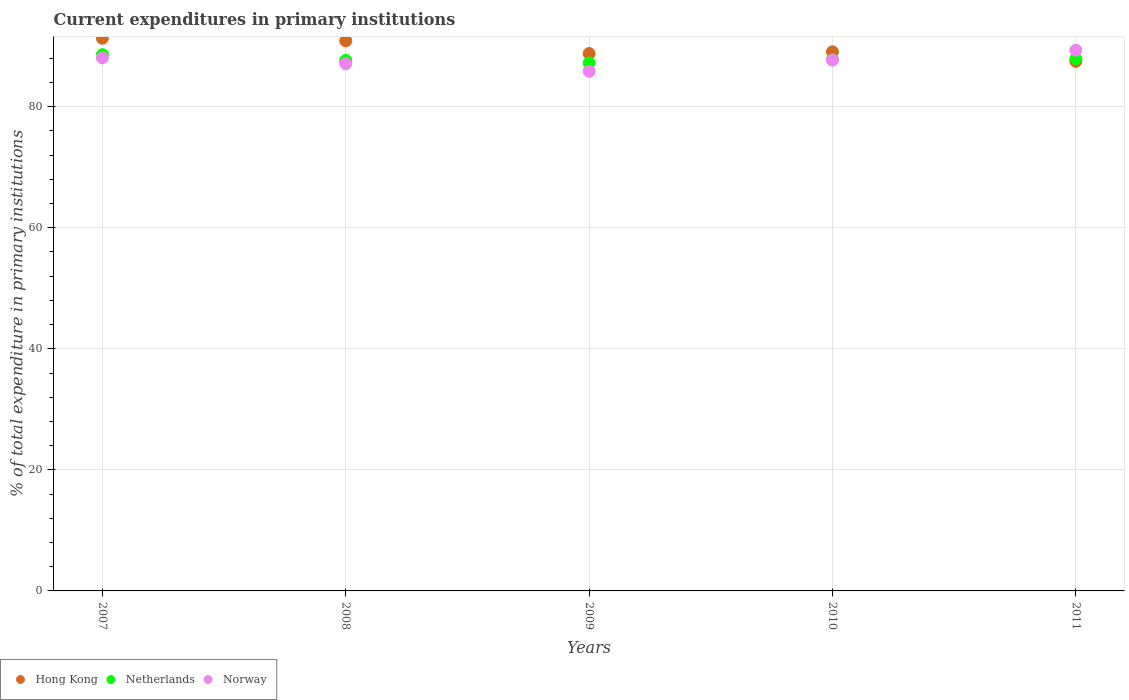Is the number of dotlines equal to the number of legend labels?
Your answer should be very brief. Yes. What is the current expenditures in primary institutions in Netherlands in 2007?
Your answer should be very brief. 88.61. Across all years, what is the maximum current expenditures in primary institutions in Norway?
Provide a short and direct response. 89.34. Across all years, what is the minimum current expenditures in primary institutions in Norway?
Keep it short and to the point. 85.87. In which year was the current expenditures in primary institutions in Norway maximum?
Your answer should be very brief. 2011. What is the total current expenditures in primary institutions in Netherlands in the graph?
Give a very brief answer. 439.27. What is the difference between the current expenditures in primary institutions in Netherlands in 2007 and that in 2010?
Your response must be concise. 0.79. What is the difference between the current expenditures in primary institutions in Hong Kong in 2010 and the current expenditures in primary institutions in Norway in 2009?
Keep it short and to the point. 3.21. What is the average current expenditures in primary institutions in Norway per year?
Your response must be concise. 87.62. In the year 2009, what is the difference between the current expenditures in primary institutions in Netherlands and current expenditures in primary institutions in Hong Kong?
Provide a succinct answer. -1.57. What is the ratio of the current expenditures in primary institutions in Hong Kong in 2007 to that in 2011?
Offer a terse response. 1.04. What is the difference between the highest and the second highest current expenditures in primary institutions in Netherlands?
Your answer should be compact. 0.66. What is the difference between the highest and the lowest current expenditures in primary institutions in Netherlands?
Your answer should be compact. 1.38. Is the sum of the current expenditures in primary institutions in Netherlands in 2008 and 2009 greater than the maximum current expenditures in primary institutions in Hong Kong across all years?
Keep it short and to the point. Yes. Is it the case that in every year, the sum of the current expenditures in primary institutions in Netherlands and current expenditures in primary institutions in Hong Kong  is greater than the current expenditures in primary institutions in Norway?
Provide a short and direct response. Yes. What is the difference between two consecutive major ticks on the Y-axis?
Provide a succinct answer. 20. Does the graph contain any zero values?
Provide a short and direct response. No. Where does the legend appear in the graph?
Provide a short and direct response. Bottom left. What is the title of the graph?
Ensure brevity in your answer.  Current expenditures in primary institutions. Does "Greenland" appear as one of the legend labels in the graph?
Provide a succinct answer. No. What is the label or title of the X-axis?
Provide a short and direct response. Years. What is the label or title of the Y-axis?
Make the answer very short. % of total expenditure in primary institutions. What is the % of total expenditure in primary institutions in Hong Kong in 2007?
Make the answer very short. 91.32. What is the % of total expenditure in primary institutions of Netherlands in 2007?
Make the answer very short. 88.61. What is the % of total expenditure in primary institutions of Norway in 2007?
Give a very brief answer. 88.1. What is the % of total expenditure in primary institutions of Hong Kong in 2008?
Your response must be concise. 90.89. What is the % of total expenditure in primary institutions of Netherlands in 2008?
Ensure brevity in your answer.  87.67. What is the % of total expenditure in primary institutions of Norway in 2008?
Keep it short and to the point. 87.1. What is the % of total expenditure in primary institutions of Hong Kong in 2009?
Ensure brevity in your answer.  88.79. What is the % of total expenditure in primary institutions in Netherlands in 2009?
Make the answer very short. 87.22. What is the % of total expenditure in primary institutions of Norway in 2009?
Offer a terse response. 85.87. What is the % of total expenditure in primary institutions of Hong Kong in 2010?
Your response must be concise. 89.08. What is the % of total expenditure in primary institutions of Netherlands in 2010?
Provide a short and direct response. 87.82. What is the % of total expenditure in primary institutions in Norway in 2010?
Your response must be concise. 87.7. What is the % of total expenditure in primary institutions of Hong Kong in 2011?
Make the answer very short. 87.5. What is the % of total expenditure in primary institutions of Netherlands in 2011?
Provide a short and direct response. 87.95. What is the % of total expenditure in primary institutions in Norway in 2011?
Give a very brief answer. 89.34. Across all years, what is the maximum % of total expenditure in primary institutions in Hong Kong?
Your answer should be very brief. 91.32. Across all years, what is the maximum % of total expenditure in primary institutions of Netherlands?
Make the answer very short. 88.61. Across all years, what is the maximum % of total expenditure in primary institutions in Norway?
Your answer should be very brief. 89.34. Across all years, what is the minimum % of total expenditure in primary institutions of Hong Kong?
Keep it short and to the point. 87.5. Across all years, what is the minimum % of total expenditure in primary institutions in Netherlands?
Provide a short and direct response. 87.22. Across all years, what is the minimum % of total expenditure in primary institutions of Norway?
Your answer should be very brief. 85.87. What is the total % of total expenditure in primary institutions of Hong Kong in the graph?
Offer a very short reply. 447.58. What is the total % of total expenditure in primary institutions in Netherlands in the graph?
Provide a succinct answer. 439.27. What is the total % of total expenditure in primary institutions of Norway in the graph?
Give a very brief answer. 438.11. What is the difference between the % of total expenditure in primary institutions in Hong Kong in 2007 and that in 2008?
Ensure brevity in your answer.  0.43. What is the difference between the % of total expenditure in primary institutions in Netherlands in 2007 and that in 2008?
Your response must be concise. 0.94. What is the difference between the % of total expenditure in primary institutions in Hong Kong in 2007 and that in 2009?
Your answer should be very brief. 2.53. What is the difference between the % of total expenditure in primary institutions in Netherlands in 2007 and that in 2009?
Provide a succinct answer. 1.38. What is the difference between the % of total expenditure in primary institutions of Norway in 2007 and that in 2009?
Your answer should be compact. 2.23. What is the difference between the % of total expenditure in primary institutions of Hong Kong in 2007 and that in 2010?
Your answer should be compact. 2.24. What is the difference between the % of total expenditure in primary institutions of Netherlands in 2007 and that in 2010?
Your answer should be very brief. 0.79. What is the difference between the % of total expenditure in primary institutions in Norway in 2007 and that in 2010?
Ensure brevity in your answer.  0.4. What is the difference between the % of total expenditure in primary institutions of Hong Kong in 2007 and that in 2011?
Ensure brevity in your answer.  3.82. What is the difference between the % of total expenditure in primary institutions of Netherlands in 2007 and that in 2011?
Your response must be concise. 0.66. What is the difference between the % of total expenditure in primary institutions of Norway in 2007 and that in 2011?
Offer a very short reply. -1.24. What is the difference between the % of total expenditure in primary institutions in Hong Kong in 2008 and that in 2009?
Your answer should be very brief. 2.1. What is the difference between the % of total expenditure in primary institutions in Netherlands in 2008 and that in 2009?
Offer a terse response. 0.44. What is the difference between the % of total expenditure in primary institutions of Norway in 2008 and that in 2009?
Your answer should be compact. 1.23. What is the difference between the % of total expenditure in primary institutions of Hong Kong in 2008 and that in 2010?
Make the answer very short. 1.81. What is the difference between the % of total expenditure in primary institutions of Netherlands in 2008 and that in 2010?
Provide a short and direct response. -0.16. What is the difference between the % of total expenditure in primary institutions in Norway in 2008 and that in 2010?
Offer a very short reply. -0.6. What is the difference between the % of total expenditure in primary institutions of Hong Kong in 2008 and that in 2011?
Your response must be concise. 3.39. What is the difference between the % of total expenditure in primary institutions in Netherlands in 2008 and that in 2011?
Provide a succinct answer. -0.28. What is the difference between the % of total expenditure in primary institutions of Norway in 2008 and that in 2011?
Your answer should be very brief. -2.24. What is the difference between the % of total expenditure in primary institutions of Hong Kong in 2009 and that in 2010?
Give a very brief answer. -0.29. What is the difference between the % of total expenditure in primary institutions of Netherlands in 2009 and that in 2010?
Ensure brevity in your answer.  -0.6. What is the difference between the % of total expenditure in primary institutions in Norway in 2009 and that in 2010?
Your response must be concise. -1.83. What is the difference between the % of total expenditure in primary institutions of Hong Kong in 2009 and that in 2011?
Your response must be concise. 1.29. What is the difference between the % of total expenditure in primary institutions in Netherlands in 2009 and that in 2011?
Make the answer very short. -0.73. What is the difference between the % of total expenditure in primary institutions of Norway in 2009 and that in 2011?
Provide a succinct answer. -3.47. What is the difference between the % of total expenditure in primary institutions of Hong Kong in 2010 and that in 2011?
Make the answer very short. 1.58. What is the difference between the % of total expenditure in primary institutions in Netherlands in 2010 and that in 2011?
Give a very brief answer. -0.13. What is the difference between the % of total expenditure in primary institutions of Norway in 2010 and that in 2011?
Make the answer very short. -1.64. What is the difference between the % of total expenditure in primary institutions in Hong Kong in 2007 and the % of total expenditure in primary institutions in Netherlands in 2008?
Provide a succinct answer. 3.66. What is the difference between the % of total expenditure in primary institutions in Hong Kong in 2007 and the % of total expenditure in primary institutions in Norway in 2008?
Ensure brevity in your answer.  4.22. What is the difference between the % of total expenditure in primary institutions in Netherlands in 2007 and the % of total expenditure in primary institutions in Norway in 2008?
Provide a succinct answer. 1.51. What is the difference between the % of total expenditure in primary institutions in Hong Kong in 2007 and the % of total expenditure in primary institutions in Netherlands in 2009?
Provide a succinct answer. 4.1. What is the difference between the % of total expenditure in primary institutions of Hong Kong in 2007 and the % of total expenditure in primary institutions of Norway in 2009?
Keep it short and to the point. 5.45. What is the difference between the % of total expenditure in primary institutions in Netherlands in 2007 and the % of total expenditure in primary institutions in Norway in 2009?
Provide a succinct answer. 2.74. What is the difference between the % of total expenditure in primary institutions in Hong Kong in 2007 and the % of total expenditure in primary institutions in Netherlands in 2010?
Your answer should be very brief. 3.5. What is the difference between the % of total expenditure in primary institutions in Hong Kong in 2007 and the % of total expenditure in primary institutions in Norway in 2010?
Ensure brevity in your answer.  3.62. What is the difference between the % of total expenditure in primary institutions in Netherlands in 2007 and the % of total expenditure in primary institutions in Norway in 2010?
Provide a succinct answer. 0.91. What is the difference between the % of total expenditure in primary institutions of Hong Kong in 2007 and the % of total expenditure in primary institutions of Netherlands in 2011?
Offer a very short reply. 3.37. What is the difference between the % of total expenditure in primary institutions of Hong Kong in 2007 and the % of total expenditure in primary institutions of Norway in 2011?
Your answer should be compact. 1.98. What is the difference between the % of total expenditure in primary institutions of Netherlands in 2007 and the % of total expenditure in primary institutions of Norway in 2011?
Offer a very short reply. -0.73. What is the difference between the % of total expenditure in primary institutions of Hong Kong in 2008 and the % of total expenditure in primary institutions of Netherlands in 2009?
Offer a very short reply. 3.67. What is the difference between the % of total expenditure in primary institutions of Hong Kong in 2008 and the % of total expenditure in primary institutions of Norway in 2009?
Ensure brevity in your answer.  5.02. What is the difference between the % of total expenditure in primary institutions of Netherlands in 2008 and the % of total expenditure in primary institutions of Norway in 2009?
Your response must be concise. 1.8. What is the difference between the % of total expenditure in primary institutions of Hong Kong in 2008 and the % of total expenditure in primary institutions of Netherlands in 2010?
Provide a succinct answer. 3.07. What is the difference between the % of total expenditure in primary institutions in Hong Kong in 2008 and the % of total expenditure in primary institutions in Norway in 2010?
Offer a terse response. 3.19. What is the difference between the % of total expenditure in primary institutions of Netherlands in 2008 and the % of total expenditure in primary institutions of Norway in 2010?
Offer a terse response. -0.03. What is the difference between the % of total expenditure in primary institutions of Hong Kong in 2008 and the % of total expenditure in primary institutions of Netherlands in 2011?
Give a very brief answer. 2.94. What is the difference between the % of total expenditure in primary institutions of Hong Kong in 2008 and the % of total expenditure in primary institutions of Norway in 2011?
Keep it short and to the point. 1.55. What is the difference between the % of total expenditure in primary institutions of Netherlands in 2008 and the % of total expenditure in primary institutions of Norway in 2011?
Ensure brevity in your answer.  -1.68. What is the difference between the % of total expenditure in primary institutions in Hong Kong in 2009 and the % of total expenditure in primary institutions in Netherlands in 2010?
Provide a short and direct response. 0.97. What is the difference between the % of total expenditure in primary institutions in Hong Kong in 2009 and the % of total expenditure in primary institutions in Norway in 2010?
Offer a terse response. 1.09. What is the difference between the % of total expenditure in primary institutions in Netherlands in 2009 and the % of total expenditure in primary institutions in Norway in 2010?
Offer a very short reply. -0.48. What is the difference between the % of total expenditure in primary institutions in Hong Kong in 2009 and the % of total expenditure in primary institutions in Netherlands in 2011?
Your answer should be compact. 0.84. What is the difference between the % of total expenditure in primary institutions in Hong Kong in 2009 and the % of total expenditure in primary institutions in Norway in 2011?
Ensure brevity in your answer.  -0.55. What is the difference between the % of total expenditure in primary institutions in Netherlands in 2009 and the % of total expenditure in primary institutions in Norway in 2011?
Make the answer very short. -2.12. What is the difference between the % of total expenditure in primary institutions in Hong Kong in 2010 and the % of total expenditure in primary institutions in Netherlands in 2011?
Give a very brief answer. 1.13. What is the difference between the % of total expenditure in primary institutions of Hong Kong in 2010 and the % of total expenditure in primary institutions of Norway in 2011?
Your answer should be very brief. -0.26. What is the difference between the % of total expenditure in primary institutions in Netherlands in 2010 and the % of total expenditure in primary institutions in Norway in 2011?
Ensure brevity in your answer.  -1.52. What is the average % of total expenditure in primary institutions in Hong Kong per year?
Your answer should be very brief. 89.52. What is the average % of total expenditure in primary institutions of Netherlands per year?
Offer a terse response. 87.85. What is the average % of total expenditure in primary institutions in Norway per year?
Offer a terse response. 87.62. In the year 2007, what is the difference between the % of total expenditure in primary institutions of Hong Kong and % of total expenditure in primary institutions of Netherlands?
Ensure brevity in your answer.  2.71. In the year 2007, what is the difference between the % of total expenditure in primary institutions of Hong Kong and % of total expenditure in primary institutions of Norway?
Make the answer very short. 3.22. In the year 2007, what is the difference between the % of total expenditure in primary institutions of Netherlands and % of total expenditure in primary institutions of Norway?
Provide a short and direct response. 0.51. In the year 2008, what is the difference between the % of total expenditure in primary institutions of Hong Kong and % of total expenditure in primary institutions of Netherlands?
Give a very brief answer. 3.23. In the year 2008, what is the difference between the % of total expenditure in primary institutions in Hong Kong and % of total expenditure in primary institutions in Norway?
Your answer should be very brief. 3.79. In the year 2008, what is the difference between the % of total expenditure in primary institutions of Netherlands and % of total expenditure in primary institutions of Norway?
Ensure brevity in your answer.  0.56. In the year 2009, what is the difference between the % of total expenditure in primary institutions in Hong Kong and % of total expenditure in primary institutions in Netherlands?
Your answer should be compact. 1.57. In the year 2009, what is the difference between the % of total expenditure in primary institutions in Hong Kong and % of total expenditure in primary institutions in Norway?
Ensure brevity in your answer.  2.92. In the year 2009, what is the difference between the % of total expenditure in primary institutions of Netherlands and % of total expenditure in primary institutions of Norway?
Provide a short and direct response. 1.35. In the year 2010, what is the difference between the % of total expenditure in primary institutions in Hong Kong and % of total expenditure in primary institutions in Netherlands?
Ensure brevity in your answer.  1.26. In the year 2010, what is the difference between the % of total expenditure in primary institutions in Hong Kong and % of total expenditure in primary institutions in Norway?
Provide a short and direct response. 1.38. In the year 2010, what is the difference between the % of total expenditure in primary institutions of Netherlands and % of total expenditure in primary institutions of Norway?
Provide a short and direct response. 0.12. In the year 2011, what is the difference between the % of total expenditure in primary institutions of Hong Kong and % of total expenditure in primary institutions of Netherlands?
Provide a succinct answer. -0.45. In the year 2011, what is the difference between the % of total expenditure in primary institutions of Hong Kong and % of total expenditure in primary institutions of Norway?
Provide a short and direct response. -1.84. In the year 2011, what is the difference between the % of total expenditure in primary institutions of Netherlands and % of total expenditure in primary institutions of Norway?
Offer a very short reply. -1.39. What is the ratio of the % of total expenditure in primary institutions in Netherlands in 2007 to that in 2008?
Provide a short and direct response. 1.01. What is the ratio of the % of total expenditure in primary institutions of Norway in 2007 to that in 2008?
Keep it short and to the point. 1.01. What is the ratio of the % of total expenditure in primary institutions of Hong Kong in 2007 to that in 2009?
Offer a terse response. 1.03. What is the ratio of the % of total expenditure in primary institutions in Netherlands in 2007 to that in 2009?
Give a very brief answer. 1.02. What is the ratio of the % of total expenditure in primary institutions of Norway in 2007 to that in 2009?
Provide a succinct answer. 1.03. What is the ratio of the % of total expenditure in primary institutions in Hong Kong in 2007 to that in 2010?
Offer a very short reply. 1.03. What is the ratio of the % of total expenditure in primary institutions in Netherlands in 2007 to that in 2010?
Your response must be concise. 1.01. What is the ratio of the % of total expenditure in primary institutions in Norway in 2007 to that in 2010?
Provide a short and direct response. 1. What is the ratio of the % of total expenditure in primary institutions of Hong Kong in 2007 to that in 2011?
Offer a very short reply. 1.04. What is the ratio of the % of total expenditure in primary institutions of Netherlands in 2007 to that in 2011?
Give a very brief answer. 1.01. What is the ratio of the % of total expenditure in primary institutions of Norway in 2007 to that in 2011?
Ensure brevity in your answer.  0.99. What is the ratio of the % of total expenditure in primary institutions in Hong Kong in 2008 to that in 2009?
Ensure brevity in your answer.  1.02. What is the ratio of the % of total expenditure in primary institutions in Netherlands in 2008 to that in 2009?
Offer a very short reply. 1.01. What is the ratio of the % of total expenditure in primary institutions of Norway in 2008 to that in 2009?
Provide a short and direct response. 1.01. What is the ratio of the % of total expenditure in primary institutions in Hong Kong in 2008 to that in 2010?
Give a very brief answer. 1.02. What is the ratio of the % of total expenditure in primary institutions in Hong Kong in 2008 to that in 2011?
Provide a short and direct response. 1.04. What is the ratio of the % of total expenditure in primary institutions in Netherlands in 2008 to that in 2011?
Ensure brevity in your answer.  1. What is the ratio of the % of total expenditure in primary institutions of Norway in 2008 to that in 2011?
Provide a short and direct response. 0.97. What is the ratio of the % of total expenditure in primary institutions of Hong Kong in 2009 to that in 2010?
Provide a short and direct response. 1. What is the ratio of the % of total expenditure in primary institutions in Norway in 2009 to that in 2010?
Provide a short and direct response. 0.98. What is the ratio of the % of total expenditure in primary institutions of Hong Kong in 2009 to that in 2011?
Make the answer very short. 1.01. What is the ratio of the % of total expenditure in primary institutions of Netherlands in 2009 to that in 2011?
Ensure brevity in your answer.  0.99. What is the ratio of the % of total expenditure in primary institutions of Norway in 2009 to that in 2011?
Offer a very short reply. 0.96. What is the ratio of the % of total expenditure in primary institutions of Hong Kong in 2010 to that in 2011?
Provide a succinct answer. 1.02. What is the ratio of the % of total expenditure in primary institutions of Netherlands in 2010 to that in 2011?
Your answer should be compact. 1. What is the ratio of the % of total expenditure in primary institutions in Norway in 2010 to that in 2011?
Offer a very short reply. 0.98. What is the difference between the highest and the second highest % of total expenditure in primary institutions of Hong Kong?
Your response must be concise. 0.43. What is the difference between the highest and the second highest % of total expenditure in primary institutions of Netherlands?
Offer a very short reply. 0.66. What is the difference between the highest and the second highest % of total expenditure in primary institutions in Norway?
Provide a succinct answer. 1.24. What is the difference between the highest and the lowest % of total expenditure in primary institutions in Hong Kong?
Keep it short and to the point. 3.82. What is the difference between the highest and the lowest % of total expenditure in primary institutions in Netherlands?
Make the answer very short. 1.38. What is the difference between the highest and the lowest % of total expenditure in primary institutions of Norway?
Make the answer very short. 3.47. 